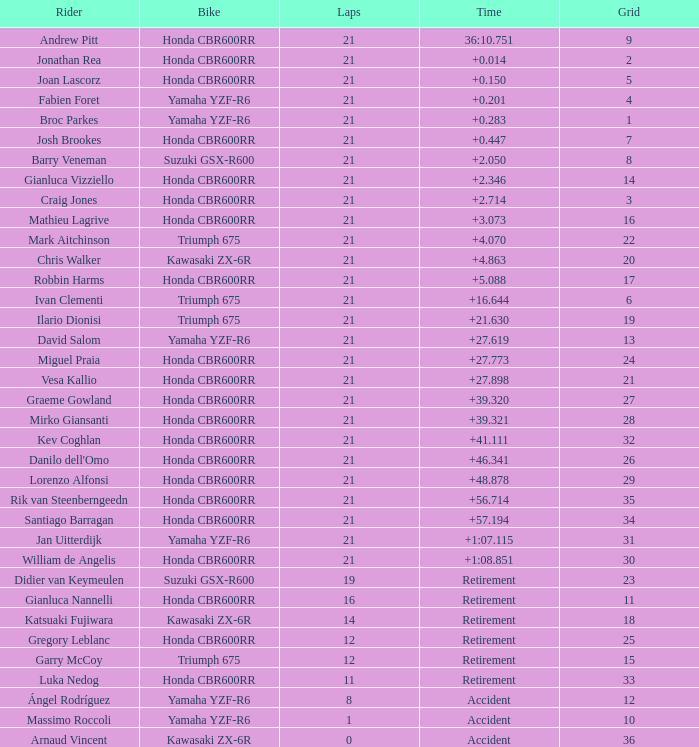Who is the rider with less than 16 laps, started from the 10th position on the grid, rode a yamaha yzf-r6, and had an accident at the end? Massimo Roccoli. 